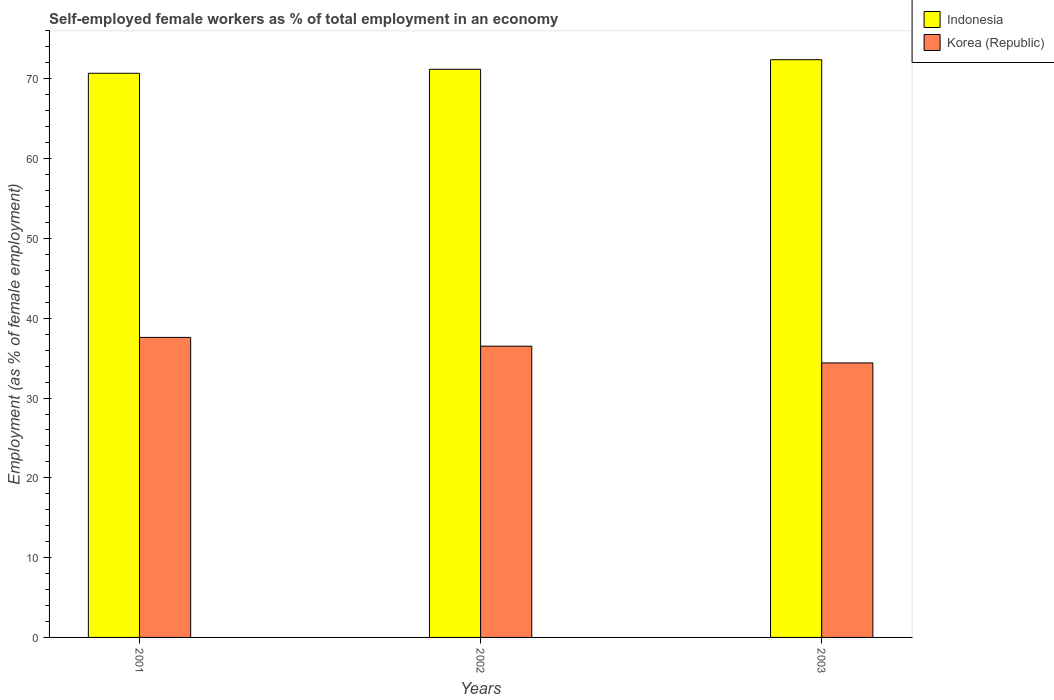How many groups of bars are there?
Give a very brief answer. 3. Are the number of bars per tick equal to the number of legend labels?
Ensure brevity in your answer.  Yes. Are the number of bars on each tick of the X-axis equal?
Offer a terse response. Yes. How many bars are there on the 3rd tick from the right?
Provide a succinct answer. 2. What is the percentage of self-employed female workers in Korea (Republic) in 2003?
Give a very brief answer. 34.4. Across all years, what is the maximum percentage of self-employed female workers in Indonesia?
Offer a terse response. 72.4. Across all years, what is the minimum percentage of self-employed female workers in Korea (Republic)?
Make the answer very short. 34.4. In which year was the percentage of self-employed female workers in Korea (Republic) maximum?
Ensure brevity in your answer.  2001. In which year was the percentage of self-employed female workers in Indonesia minimum?
Keep it short and to the point. 2001. What is the total percentage of self-employed female workers in Indonesia in the graph?
Your answer should be compact. 214.3. What is the difference between the percentage of self-employed female workers in Indonesia in 2001 and that in 2003?
Keep it short and to the point. -1.7. What is the difference between the percentage of self-employed female workers in Indonesia in 2003 and the percentage of self-employed female workers in Korea (Republic) in 2001?
Provide a succinct answer. 34.8. What is the average percentage of self-employed female workers in Indonesia per year?
Make the answer very short. 71.43. In the year 2001, what is the difference between the percentage of self-employed female workers in Indonesia and percentage of self-employed female workers in Korea (Republic)?
Make the answer very short. 33.1. In how many years, is the percentage of self-employed female workers in Indonesia greater than 20 %?
Give a very brief answer. 3. What is the ratio of the percentage of self-employed female workers in Indonesia in 2002 to that in 2003?
Provide a succinct answer. 0.98. What is the difference between the highest and the second highest percentage of self-employed female workers in Korea (Republic)?
Keep it short and to the point. 1.1. What is the difference between the highest and the lowest percentage of self-employed female workers in Indonesia?
Provide a short and direct response. 1.7. What does the 1st bar from the left in 2003 represents?
Make the answer very short. Indonesia. How many bars are there?
Your answer should be very brief. 6. How many years are there in the graph?
Ensure brevity in your answer.  3. What is the difference between two consecutive major ticks on the Y-axis?
Keep it short and to the point. 10. Where does the legend appear in the graph?
Make the answer very short. Top right. How many legend labels are there?
Your response must be concise. 2. How are the legend labels stacked?
Provide a short and direct response. Vertical. What is the title of the graph?
Offer a very short reply. Self-employed female workers as % of total employment in an economy. Does "El Salvador" appear as one of the legend labels in the graph?
Ensure brevity in your answer.  No. What is the label or title of the X-axis?
Ensure brevity in your answer.  Years. What is the label or title of the Y-axis?
Provide a short and direct response. Employment (as % of female employment). What is the Employment (as % of female employment) of Indonesia in 2001?
Provide a succinct answer. 70.7. What is the Employment (as % of female employment) in Korea (Republic) in 2001?
Keep it short and to the point. 37.6. What is the Employment (as % of female employment) in Indonesia in 2002?
Your answer should be very brief. 71.2. What is the Employment (as % of female employment) in Korea (Republic) in 2002?
Make the answer very short. 36.5. What is the Employment (as % of female employment) of Indonesia in 2003?
Your answer should be very brief. 72.4. What is the Employment (as % of female employment) of Korea (Republic) in 2003?
Provide a short and direct response. 34.4. Across all years, what is the maximum Employment (as % of female employment) of Indonesia?
Your answer should be very brief. 72.4. Across all years, what is the maximum Employment (as % of female employment) in Korea (Republic)?
Make the answer very short. 37.6. Across all years, what is the minimum Employment (as % of female employment) of Indonesia?
Your answer should be very brief. 70.7. Across all years, what is the minimum Employment (as % of female employment) of Korea (Republic)?
Keep it short and to the point. 34.4. What is the total Employment (as % of female employment) of Indonesia in the graph?
Your answer should be compact. 214.3. What is the total Employment (as % of female employment) of Korea (Republic) in the graph?
Make the answer very short. 108.5. What is the difference between the Employment (as % of female employment) of Indonesia in 2001 and that in 2002?
Provide a short and direct response. -0.5. What is the difference between the Employment (as % of female employment) in Korea (Republic) in 2001 and that in 2002?
Offer a terse response. 1.1. What is the difference between the Employment (as % of female employment) in Indonesia in 2001 and that in 2003?
Offer a very short reply. -1.7. What is the difference between the Employment (as % of female employment) in Indonesia in 2002 and that in 2003?
Offer a very short reply. -1.2. What is the difference between the Employment (as % of female employment) in Indonesia in 2001 and the Employment (as % of female employment) in Korea (Republic) in 2002?
Ensure brevity in your answer.  34.2. What is the difference between the Employment (as % of female employment) in Indonesia in 2001 and the Employment (as % of female employment) in Korea (Republic) in 2003?
Provide a succinct answer. 36.3. What is the difference between the Employment (as % of female employment) in Indonesia in 2002 and the Employment (as % of female employment) in Korea (Republic) in 2003?
Make the answer very short. 36.8. What is the average Employment (as % of female employment) of Indonesia per year?
Keep it short and to the point. 71.43. What is the average Employment (as % of female employment) in Korea (Republic) per year?
Make the answer very short. 36.17. In the year 2001, what is the difference between the Employment (as % of female employment) of Indonesia and Employment (as % of female employment) of Korea (Republic)?
Offer a terse response. 33.1. In the year 2002, what is the difference between the Employment (as % of female employment) of Indonesia and Employment (as % of female employment) of Korea (Republic)?
Provide a short and direct response. 34.7. What is the ratio of the Employment (as % of female employment) in Indonesia in 2001 to that in 2002?
Keep it short and to the point. 0.99. What is the ratio of the Employment (as % of female employment) in Korea (Republic) in 2001 to that in 2002?
Offer a terse response. 1.03. What is the ratio of the Employment (as % of female employment) in Indonesia in 2001 to that in 2003?
Your answer should be compact. 0.98. What is the ratio of the Employment (as % of female employment) in Korea (Republic) in 2001 to that in 2003?
Ensure brevity in your answer.  1.09. What is the ratio of the Employment (as % of female employment) in Indonesia in 2002 to that in 2003?
Ensure brevity in your answer.  0.98. What is the ratio of the Employment (as % of female employment) in Korea (Republic) in 2002 to that in 2003?
Provide a succinct answer. 1.06. What is the difference between the highest and the second highest Employment (as % of female employment) of Korea (Republic)?
Your answer should be compact. 1.1. 